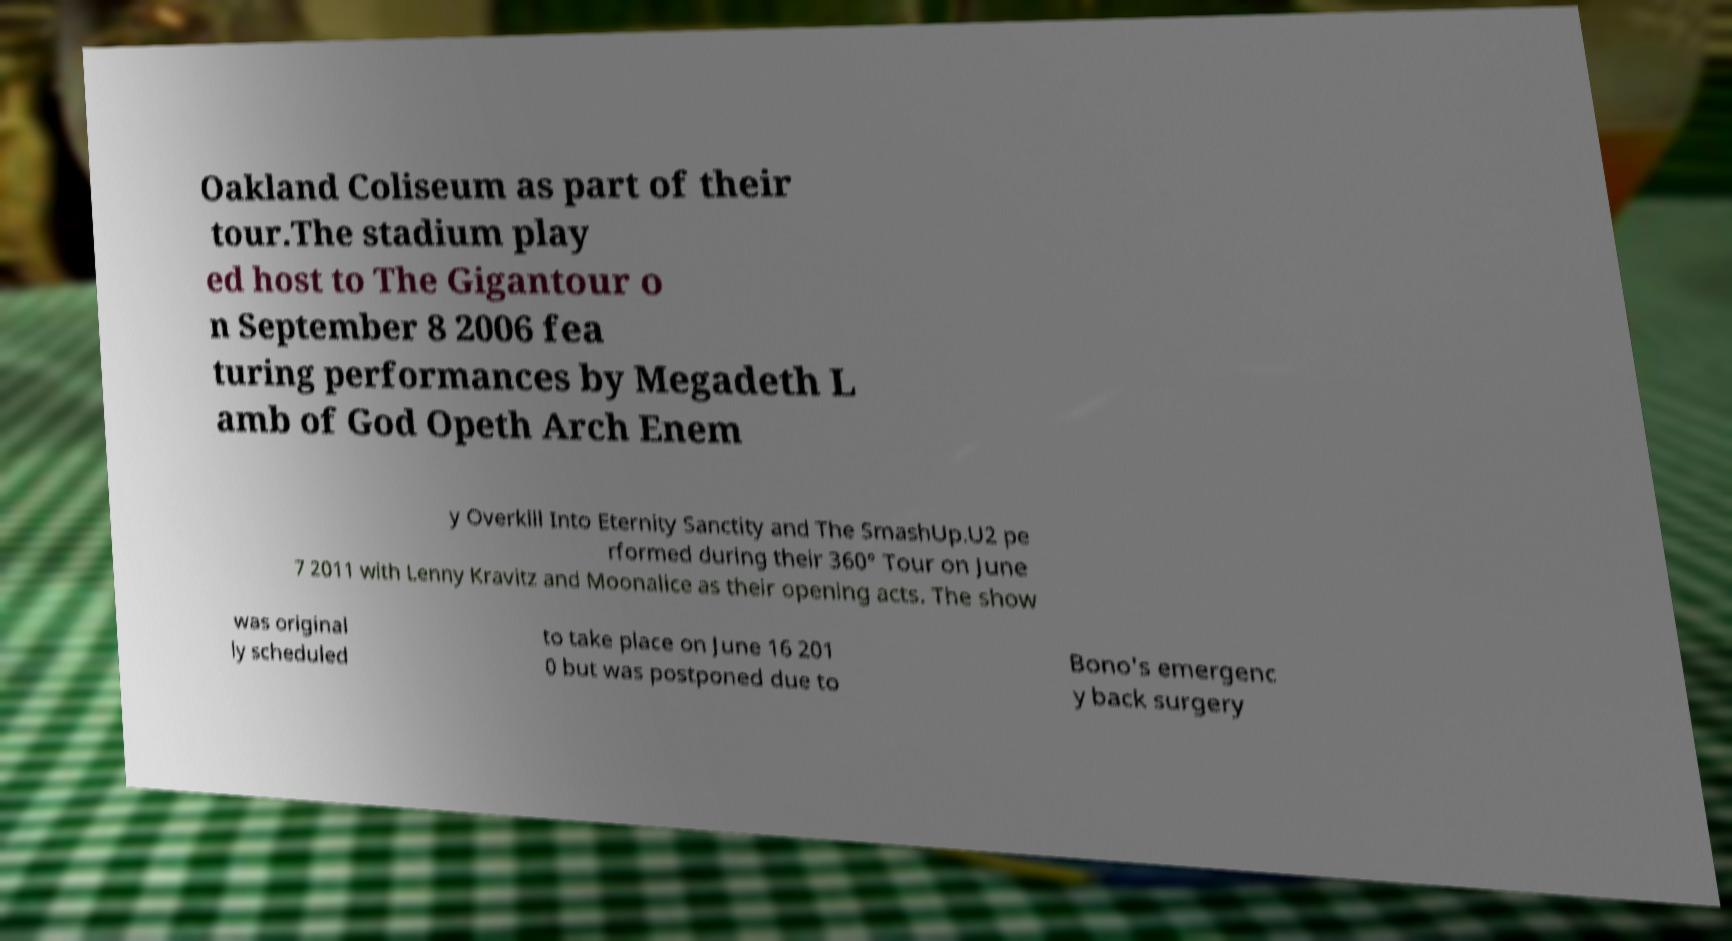I need the written content from this picture converted into text. Can you do that? Oakland Coliseum as part of their tour.The stadium play ed host to The Gigantour o n September 8 2006 fea turing performances by Megadeth L amb of God Opeth Arch Enem y Overkill Into Eternity Sanctity and The SmashUp.U2 pe rformed during their 360° Tour on June 7 2011 with Lenny Kravitz and Moonalice as their opening acts. The show was original ly scheduled to take place on June 16 201 0 but was postponed due to Bono's emergenc y back surgery 